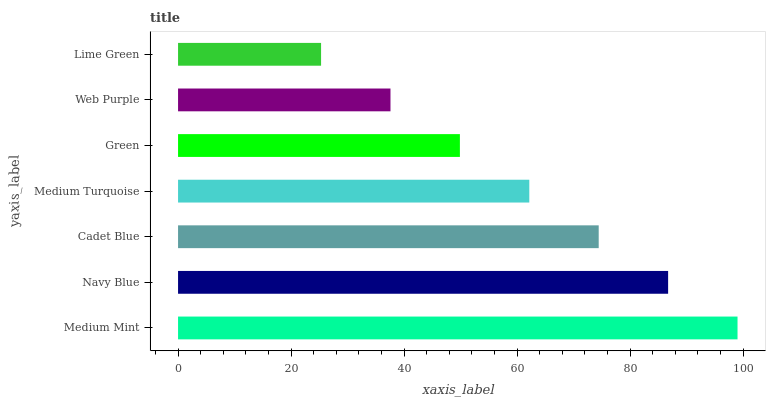Is Lime Green the minimum?
Answer yes or no. Yes. Is Medium Mint the maximum?
Answer yes or no. Yes. Is Navy Blue the minimum?
Answer yes or no. No. Is Navy Blue the maximum?
Answer yes or no. No. Is Medium Mint greater than Navy Blue?
Answer yes or no. Yes. Is Navy Blue less than Medium Mint?
Answer yes or no. Yes. Is Navy Blue greater than Medium Mint?
Answer yes or no. No. Is Medium Mint less than Navy Blue?
Answer yes or no. No. Is Medium Turquoise the high median?
Answer yes or no. Yes. Is Medium Turquoise the low median?
Answer yes or no. Yes. Is Web Purple the high median?
Answer yes or no. No. Is Medium Mint the low median?
Answer yes or no. No. 